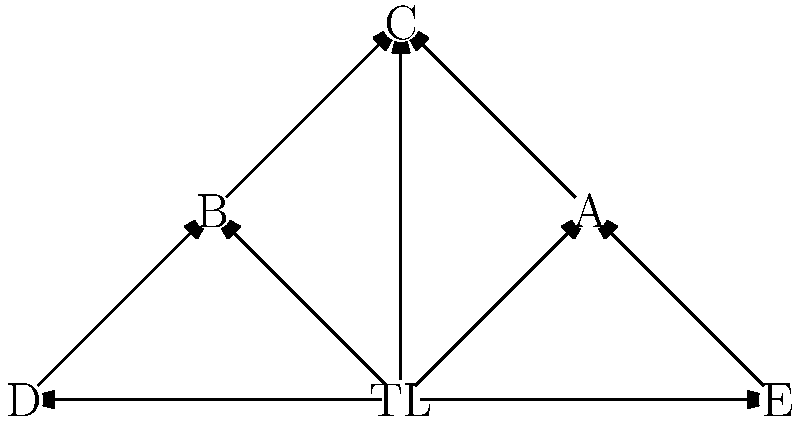Based on the network diagram representing communication patterns within a team, which team member appears to be the most isolated and potentially in need of better integration into the team's communication structure? To determine the most isolated team member, we need to analyze the communication patterns shown in the network diagram:

1. TL (Team Leader) is at the center and connects to all other team members (A, B, C, D, E).
2. A is connected to TL, C, and E.
3. B is connected to TL, C, and D.
4. C is connected to TL, A, and B.
5. D is connected to TL and B.
6. E is connected to TL and A.

Analyzing the connections:
- TL has 5 connections
- A has 3 connections
- B has 3 connections
- C has 3 connections
- D has 2 connections
- E has 2 connections

D and E have the fewest connections (2 each). However, E is connected to both TL and A, while D is connected to TL and B. This means that D has slightly less diverse communication channels compared to E.

Therefore, D appears to be the most isolated team member and potentially in need of better integration into the team's communication structure.
Answer: D 